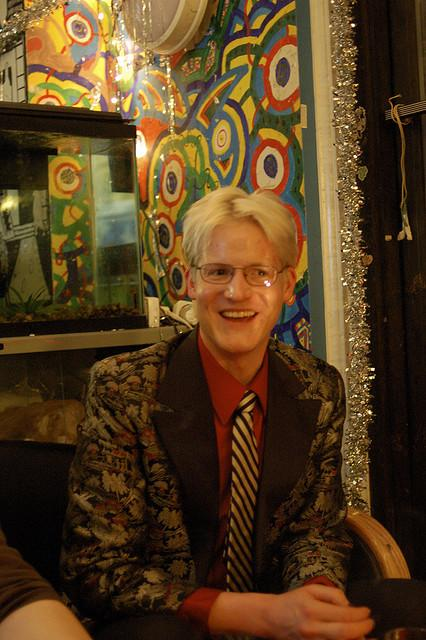What is the gold lining in the doorway called? tinsel 